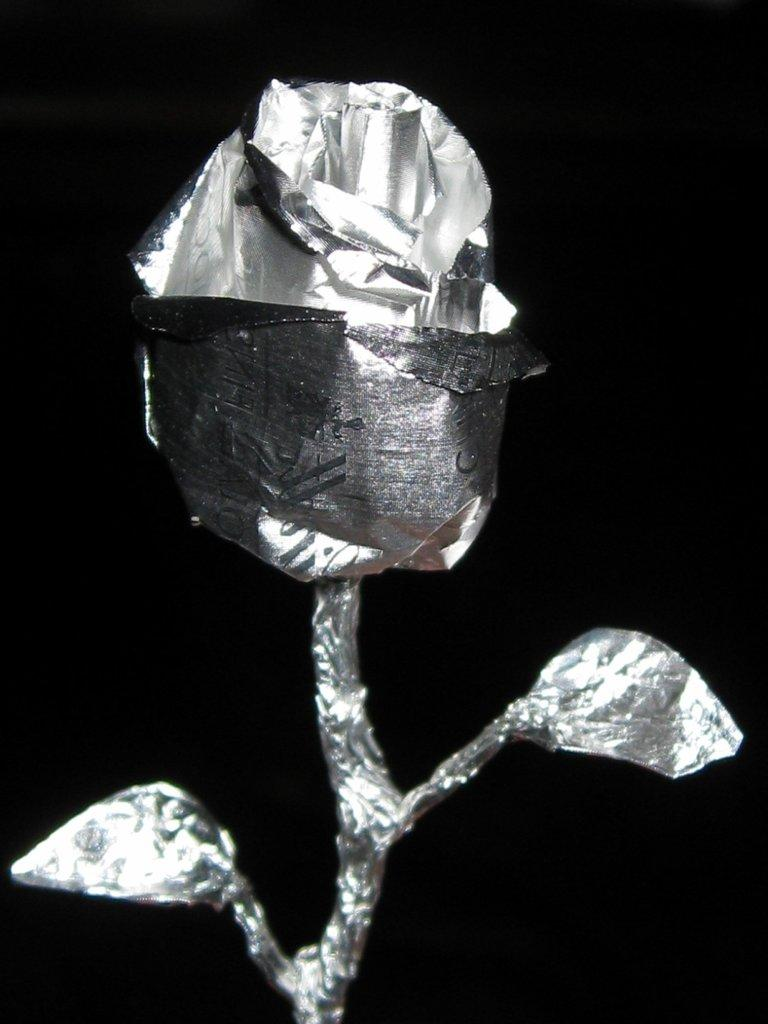What is the color scheme of the image? The image is black and white. What type of object can be seen in the image? There is an artificial flower in the image. What color is the background of the image? The background of the image is black. What type of fact can be found in the image? There are no facts present in the image, as it is a visual representation and not a source of information. 